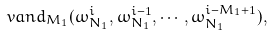Convert formula to latex. <formula><loc_0><loc_0><loc_500><loc_500>\ v a n d _ { M _ { 1 } } ( \omega _ { N _ { 1 } } ^ { i } , \omega _ { N _ { 1 } } ^ { i - 1 } , \cdots , \omega _ { N _ { 1 } } ^ { i - M _ { 1 } + 1 } ) ,</formula> 